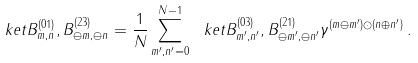Convert formula to latex. <formula><loc_0><loc_0><loc_500><loc_500>\ k e t { B ^ { ( 0 1 ) } _ { m , n } , B ^ { ( 2 3 ) } _ { \ominus m , \ominus n } } = \frac { 1 } { N } \sum _ { m ^ { \prime } , n ^ { \prime } = 0 } ^ { N - 1 } \ k e t { B ^ { ( 0 3 ) } _ { m ^ { \prime } , n ^ { \prime } } , B ^ { ( 2 1 ) } _ { \ominus m ^ { \prime } , \ominus n ^ { \prime } } } \gamma ^ { ( m \ominus m ^ { \prime } ) \odot ( n \oplus n ^ { \prime } ) } \, .</formula> 